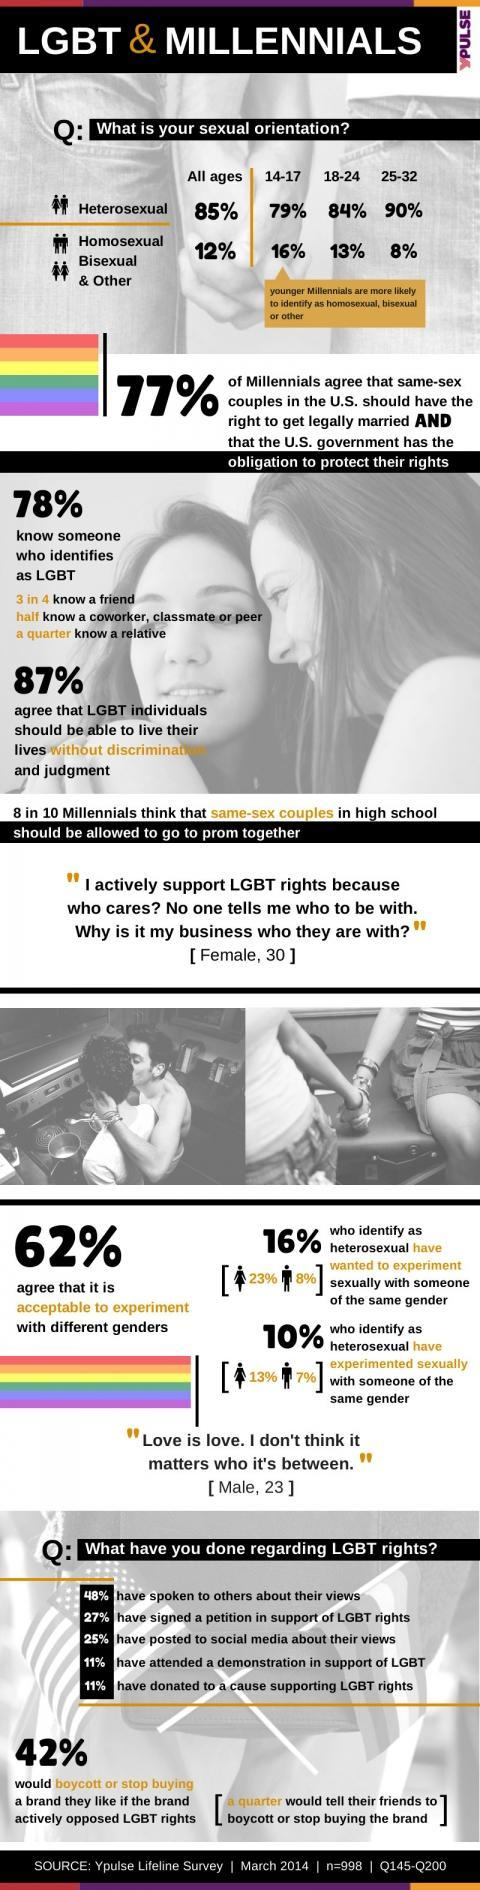Which age group has second highest number of LGBT?
Answer the question with a short phrase. 18-24 